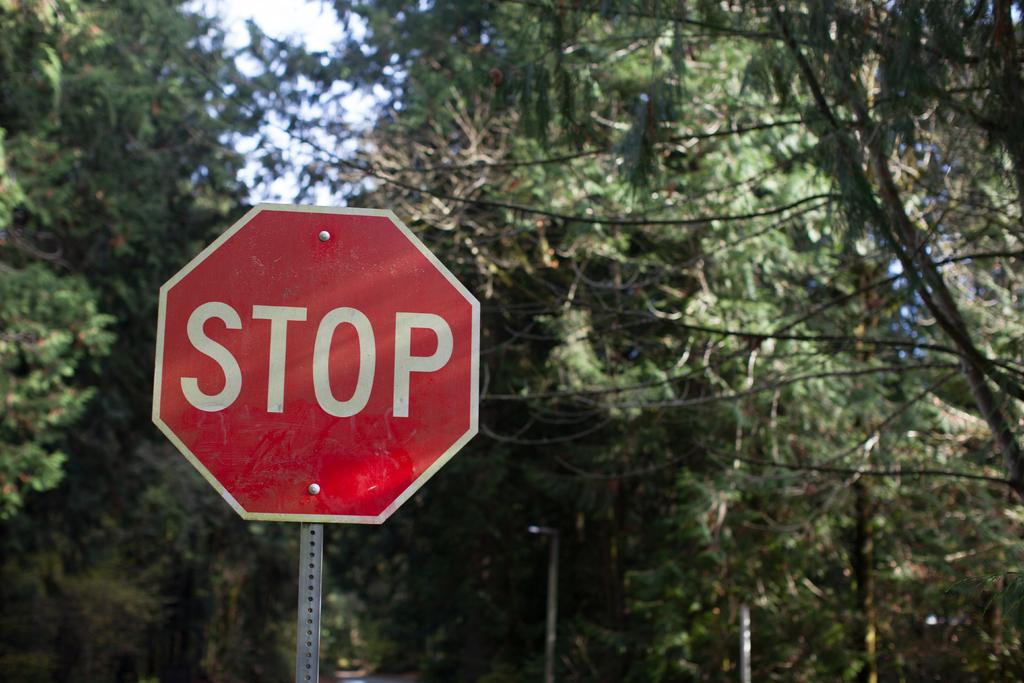<image>
Create a compact narrative representing the image presented. A STOP sign in the middle of a pine forrest 